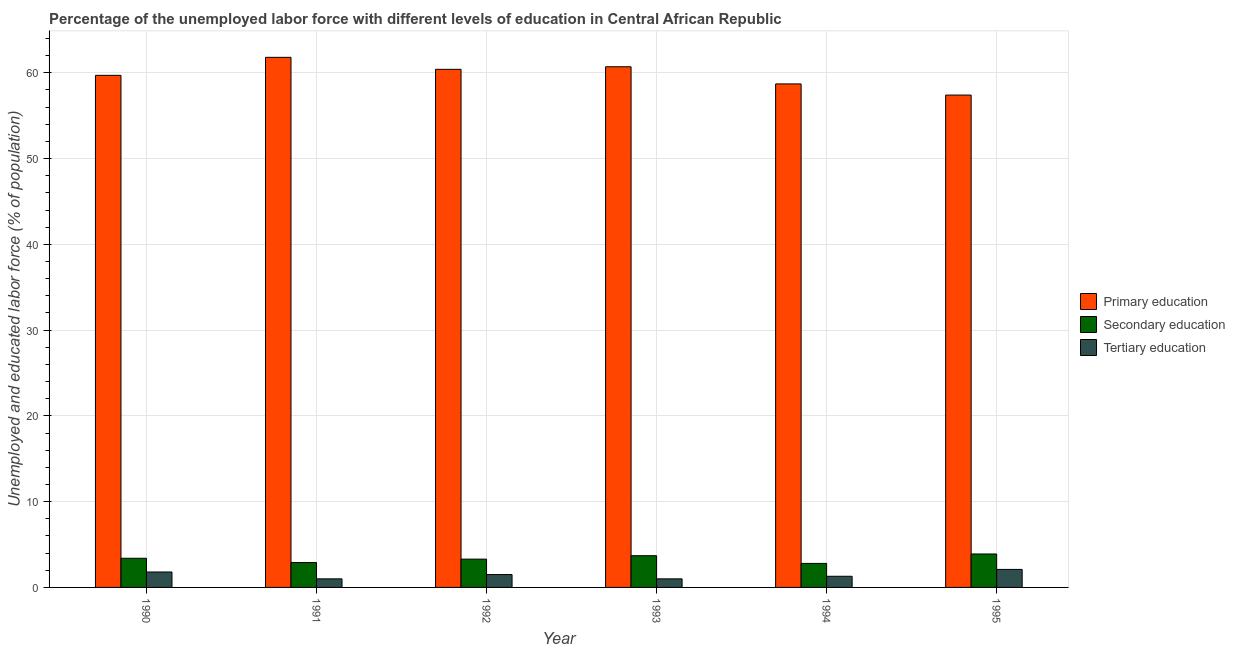Are the number of bars on each tick of the X-axis equal?
Your response must be concise. Yes. What is the label of the 4th group of bars from the left?
Your response must be concise. 1993. What is the percentage of labor force who received secondary education in 1995?
Ensure brevity in your answer.  3.9. Across all years, what is the maximum percentage of labor force who received primary education?
Ensure brevity in your answer.  61.8. Across all years, what is the minimum percentage of labor force who received tertiary education?
Your answer should be compact. 1. What is the total percentage of labor force who received secondary education in the graph?
Make the answer very short. 20. What is the difference between the percentage of labor force who received secondary education in 1994 and that in 1995?
Give a very brief answer. -1.1. What is the difference between the percentage of labor force who received secondary education in 1995 and the percentage of labor force who received tertiary education in 1994?
Make the answer very short. 1.1. What is the average percentage of labor force who received tertiary education per year?
Your response must be concise. 1.45. In the year 1993, what is the difference between the percentage of labor force who received primary education and percentage of labor force who received secondary education?
Your answer should be very brief. 0. What is the ratio of the percentage of labor force who received primary education in 1992 to that in 1993?
Provide a short and direct response. 1. Is the percentage of labor force who received secondary education in 1991 less than that in 1992?
Offer a very short reply. Yes. What is the difference between the highest and the second highest percentage of labor force who received tertiary education?
Your answer should be compact. 0.3. What is the difference between the highest and the lowest percentage of labor force who received secondary education?
Offer a very short reply. 1.1. Is the sum of the percentage of labor force who received tertiary education in 1992 and 1994 greater than the maximum percentage of labor force who received primary education across all years?
Your answer should be very brief. Yes. What does the 3rd bar from the left in 1990 represents?
Provide a succinct answer. Tertiary education. What does the 2nd bar from the right in 1995 represents?
Provide a short and direct response. Secondary education. Is it the case that in every year, the sum of the percentage of labor force who received primary education and percentage of labor force who received secondary education is greater than the percentage of labor force who received tertiary education?
Give a very brief answer. Yes. Are all the bars in the graph horizontal?
Keep it short and to the point. No. What is the difference between two consecutive major ticks on the Y-axis?
Give a very brief answer. 10. Does the graph contain grids?
Provide a succinct answer. Yes. What is the title of the graph?
Ensure brevity in your answer.  Percentage of the unemployed labor force with different levels of education in Central African Republic. What is the label or title of the Y-axis?
Offer a very short reply. Unemployed and educated labor force (% of population). What is the Unemployed and educated labor force (% of population) of Primary education in 1990?
Give a very brief answer. 59.7. What is the Unemployed and educated labor force (% of population) of Secondary education in 1990?
Offer a terse response. 3.4. What is the Unemployed and educated labor force (% of population) of Tertiary education in 1990?
Provide a succinct answer. 1.8. What is the Unemployed and educated labor force (% of population) in Primary education in 1991?
Your answer should be compact. 61.8. What is the Unemployed and educated labor force (% of population) of Secondary education in 1991?
Your answer should be compact. 2.9. What is the Unemployed and educated labor force (% of population) of Primary education in 1992?
Provide a short and direct response. 60.4. What is the Unemployed and educated labor force (% of population) in Secondary education in 1992?
Keep it short and to the point. 3.3. What is the Unemployed and educated labor force (% of population) of Primary education in 1993?
Provide a succinct answer. 60.7. What is the Unemployed and educated labor force (% of population) in Secondary education in 1993?
Give a very brief answer. 3.7. What is the Unemployed and educated labor force (% of population) in Primary education in 1994?
Give a very brief answer. 58.7. What is the Unemployed and educated labor force (% of population) of Secondary education in 1994?
Make the answer very short. 2.8. What is the Unemployed and educated labor force (% of population) of Tertiary education in 1994?
Provide a short and direct response. 1.3. What is the Unemployed and educated labor force (% of population) of Primary education in 1995?
Offer a terse response. 57.4. What is the Unemployed and educated labor force (% of population) in Secondary education in 1995?
Make the answer very short. 3.9. What is the Unemployed and educated labor force (% of population) of Tertiary education in 1995?
Give a very brief answer. 2.1. Across all years, what is the maximum Unemployed and educated labor force (% of population) of Primary education?
Provide a short and direct response. 61.8. Across all years, what is the maximum Unemployed and educated labor force (% of population) in Secondary education?
Your response must be concise. 3.9. Across all years, what is the maximum Unemployed and educated labor force (% of population) in Tertiary education?
Ensure brevity in your answer.  2.1. Across all years, what is the minimum Unemployed and educated labor force (% of population) in Primary education?
Offer a very short reply. 57.4. Across all years, what is the minimum Unemployed and educated labor force (% of population) in Secondary education?
Offer a terse response. 2.8. What is the total Unemployed and educated labor force (% of population) in Primary education in the graph?
Offer a terse response. 358.7. What is the total Unemployed and educated labor force (% of population) of Secondary education in the graph?
Your answer should be compact. 20. What is the total Unemployed and educated labor force (% of population) in Tertiary education in the graph?
Provide a succinct answer. 8.7. What is the difference between the Unemployed and educated labor force (% of population) of Secondary education in 1990 and that in 1991?
Make the answer very short. 0.5. What is the difference between the Unemployed and educated labor force (% of population) in Tertiary education in 1990 and that in 1991?
Provide a short and direct response. 0.8. What is the difference between the Unemployed and educated labor force (% of population) in Primary education in 1990 and that in 1993?
Your answer should be very brief. -1. What is the difference between the Unemployed and educated labor force (% of population) in Tertiary education in 1990 and that in 1993?
Offer a very short reply. 0.8. What is the difference between the Unemployed and educated labor force (% of population) in Secondary education in 1990 and that in 1994?
Offer a terse response. 0.6. What is the difference between the Unemployed and educated labor force (% of population) in Tertiary education in 1990 and that in 1994?
Keep it short and to the point. 0.5. What is the difference between the Unemployed and educated labor force (% of population) of Secondary education in 1990 and that in 1995?
Make the answer very short. -0.5. What is the difference between the Unemployed and educated labor force (% of population) in Tertiary education in 1990 and that in 1995?
Offer a terse response. -0.3. What is the difference between the Unemployed and educated labor force (% of population) of Primary education in 1991 and that in 1992?
Keep it short and to the point. 1.4. What is the difference between the Unemployed and educated labor force (% of population) in Secondary education in 1991 and that in 1992?
Give a very brief answer. -0.4. What is the difference between the Unemployed and educated labor force (% of population) of Tertiary education in 1991 and that in 1992?
Your answer should be very brief. -0.5. What is the difference between the Unemployed and educated labor force (% of population) of Secondary education in 1991 and that in 1993?
Make the answer very short. -0.8. What is the difference between the Unemployed and educated labor force (% of population) of Secondary education in 1991 and that in 1994?
Offer a terse response. 0.1. What is the difference between the Unemployed and educated labor force (% of population) of Tertiary education in 1991 and that in 1995?
Your response must be concise. -1.1. What is the difference between the Unemployed and educated labor force (% of population) of Secondary education in 1992 and that in 1993?
Your answer should be compact. -0.4. What is the difference between the Unemployed and educated labor force (% of population) in Primary education in 1992 and that in 1994?
Offer a very short reply. 1.7. What is the difference between the Unemployed and educated labor force (% of population) of Tertiary education in 1992 and that in 1994?
Provide a succinct answer. 0.2. What is the difference between the Unemployed and educated labor force (% of population) in Secondary education in 1992 and that in 1995?
Provide a succinct answer. -0.6. What is the difference between the Unemployed and educated labor force (% of population) in Primary education in 1993 and that in 1994?
Give a very brief answer. 2. What is the difference between the Unemployed and educated labor force (% of population) in Secondary education in 1993 and that in 1994?
Ensure brevity in your answer.  0.9. What is the difference between the Unemployed and educated labor force (% of population) in Secondary education in 1994 and that in 1995?
Provide a short and direct response. -1.1. What is the difference between the Unemployed and educated labor force (% of population) of Tertiary education in 1994 and that in 1995?
Ensure brevity in your answer.  -0.8. What is the difference between the Unemployed and educated labor force (% of population) in Primary education in 1990 and the Unemployed and educated labor force (% of population) in Secondary education in 1991?
Provide a succinct answer. 56.8. What is the difference between the Unemployed and educated labor force (% of population) in Primary education in 1990 and the Unemployed and educated labor force (% of population) in Tertiary education in 1991?
Provide a succinct answer. 58.7. What is the difference between the Unemployed and educated labor force (% of population) in Primary education in 1990 and the Unemployed and educated labor force (% of population) in Secondary education in 1992?
Provide a short and direct response. 56.4. What is the difference between the Unemployed and educated labor force (% of population) in Primary education in 1990 and the Unemployed and educated labor force (% of population) in Tertiary education in 1992?
Provide a short and direct response. 58.2. What is the difference between the Unemployed and educated labor force (% of population) of Secondary education in 1990 and the Unemployed and educated labor force (% of population) of Tertiary education in 1992?
Offer a very short reply. 1.9. What is the difference between the Unemployed and educated labor force (% of population) in Primary education in 1990 and the Unemployed and educated labor force (% of population) in Tertiary education in 1993?
Make the answer very short. 58.7. What is the difference between the Unemployed and educated labor force (% of population) in Secondary education in 1990 and the Unemployed and educated labor force (% of population) in Tertiary education in 1993?
Offer a terse response. 2.4. What is the difference between the Unemployed and educated labor force (% of population) in Primary education in 1990 and the Unemployed and educated labor force (% of population) in Secondary education in 1994?
Make the answer very short. 56.9. What is the difference between the Unemployed and educated labor force (% of population) of Primary education in 1990 and the Unemployed and educated labor force (% of population) of Tertiary education in 1994?
Offer a terse response. 58.4. What is the difference between the Unemployed and educated labor force (% of population) of Primary education in 1990 and the Unemployed and educated labor force (% of population) of Secondary education in 1995?
Your response must be concise. 55.8. What is the difference between the Unemployed and educated labor force (% of population) in Primary education in 1990 and the Unemployed and educated labor force (% of population) in Tertiary education in 1995?
Offer a very short reply. 57.6. What is the difference between the Unemployed and educated labor force (% of population) of Primary education in 1991 and the Unemployed and educated labor force (% of population) of Secondary education in 1992?
Provide a short and direct response. 58.5. What is the difference between the Unemployed and educated labor force (% of population) of Primary education in 1991 and the Unemployed and educated labor force (% of population) of Tertiary education in 1992?
Offer a very short reply. 60.3. What is the difference between the Unemployed and educated labor force (% of population) of Primary education in 1991 and the Unemployed and educated labor force (% of population) of Secondary education in 1993?
Offer a very short reply. 58.1. What is the difference between the Unemployed and educated labor force (% of population) of Primary education in 1991 and the Unemployed and educated labor force (% of population) of Tertiary education in 1993?
Keep it short and to the point. 60.8. What is the difference between the Unemployed and educated labor force (% of population) of Secondary education in 1991 and the Unemployed and educated labor force (% of population) of Tertiary education in 1993?
Provide a succinct answer. 1.9. What is the difference between the Unemployed and educated labor force (% of population) of Primary education in 1991 and the Unemployed and educated labor force (% of population) of Secondary education in 1994?
Provide a short and direct response. 59. What is the difference between the Unemployed and educated labor force (% of population) of Primary education in 1991 and the Unemployed and educated labor force (% of population) of Tertiary education in 1994?
Give a very brief answer. 60.5. What is the difference between the Unemployed and educated labor force (% of population) of Primary education in 1991 and the Unemployed and educated labor force (% of population) of Secondary education in 1995?
Keep it short and to the point. 57.9. What is the difference between the Unemployed and educated labor force (% of population) in Primary education in 1991 and the Unemployed and educated labor force (% of population) in Tertiary education in 1995?
Give a very brief answer. 59.7. What is the difference between the Unemployed and educated labor force (% of population) in Primary education in 1992 and the Unemployed and educated labor force (% of population) in Secondary education in 1993?
Provide a succinct answer. 56.7. What is the difference between the Unemployed and educated labor force (% of population) of Primary education in 1992 and the Unemployed and educated labor force (% of population) of Tertiary education in 1993?
Your answer should be compact. 59.4. What is the difference between the Unemployed and educated labor force (% of population) of Primary education in 1992 and the Unemployed and educated labor force (% of population) of Secondary education in 1994?
Offer a terse response. 57.6. What is the difference between the Unemployed and educated labor force (% of population) of Primary education in 1992 and the Unemployed and educated labor force (% of population) of Tertiary education in 1994?
Offer a terse response. 59.1. What is the difference between the Unemployed and educated labor force (% of population) of Primary education in 1992 and the Unemployed and educated labor force (% of population) of Secondary education in 1995?
Your response must be concise. 56.5. What is the difference between the Unemployed and educated labor force (% of population) of Primary education in 1992 and the Unemployed and educated labor force (% of population) of Tertiary education in 1995?
Offer a terse response. 58.3. What is the difference between the Unemployed and educated labor force (% of population) of Secondary education in 1992 and the Unemployed and educated labor force (% of population) of Tertiary education in 1995?
Offer a very short reply. 1.2. What is the difference between the Unemployed and educated labor force (% of population) in Primary education in 1993 and the Unemployed and educated labor force (% of population) in Secondary education in 1994?
Your answer should be compact. 57.9. What is the difference between the Unemployed and educated labor force (% of population) in Primary education in 1993 and the Unemployed and educated labor force (% of population) in Tertiary education in 1994?
Your answer should be very brief. 59.4. What is the difference between the Unemployed and educated labor force (% of population) in Secondary education in 1993 and the Unemployed and educated labor force (% of population) in Tertiary education in 1994?
Offer a very short reply. 2.4. What is the difference between the Unemployed and educated labor force (% of population) of Primary education in 1993 and the Unemployed and educated labor force (% of population) of Secondary education in 1995?
Provide a short and direct response. 56.8. What is the difference between the Unemployed and educated labor force (% of population) in Primary education in 1993 and the Unemployed and educated labor force (% of population) in Tertiary education in 1995?
Your answer should be compact. 58.6. What is the difference between the Unemployed and educated labor force (% of population) of Primary education in 1994 and the Unemployed and educated labor force (% of population) of Secondary education in 1995?
Provide a short and direct response. 54.8. What is the difference between the Unemployed and educated labor force (% of population) of Primary education in 1994 and the Unemployed and educated labor force (% of population) of Tertiary education in 1995?
Offer a terse response. 56.6. What is the average Unemployed and educated labor force (% of population) of Primary education per year?
Give a very brief answer. 59.78. What is the average Unemployed and educated labor force (% of population) of Secondary education per year?
Offer a very short reply. 3.33. What is the average Unemployed and educated labor force (% of population) of Tertiary education per year?
Make the answer very short. 1.45. In the year 1990, what is the difference between the Unemployed and educated labor force (% of population) in Primary education and Unemployed and educated labor force (% of population) in Secondary education?
Provide a succinct answer. 56.3. In the year 1990, what is the difference between the Unemployed and educated labor force (% of population) in Primary education and Unemployed and educated labor force (% of population) in Tertiary education?
Give a very brief answer. 57.9. In the year 1990, what is the difference between the Unemployed and educated labor force (% of population) in Secondary education and Unemployed and educated labor force (% of population) in Tertiary education?
Provide a short and direct response. 1.6. In the year 1991, what is the difference between the Unemployed and educated labor force (% of population) of Primary education and Unemployed and educated labor force (% of population) of Secondary education?
Ensure brevity in your answer.  58.9. In the year 1991, what is the difference between the Unemployed and educated labor force (% of population) in Primary education and Unemployed and educated labor force (% of population) in Tertiary education?
Make the answer very short. 60.8. In the year 1992, what is the difference between the Unemployed and educated labor force (% of population) in Primary education and Unemployed and educated labor force (% of population) in Secondary education?
Your response must be concise. 57.1. In the year 1992, what is the difference between the Unemployed and educated labor force (% of population) of Primary education and Unemployed and educated labor force (% of population) of Tertiary education?
Provide a succinct answer. 58.9. In the year 1993, what is the difference between the Unemployed and educated labor force (% of population) in Primary education and Unemployed and educated labor force (% of population) in Tertiary education?
Provide a short and direct response. 59.7. In the year 1993, what is the difference between the Unemployed and educated labor force (% of population) in Secondary education and Unemployed and educated labor force (% of population) in Tertiary education?
Your answer should be compact. 2.7. In the year 1994, what is the difference between the Unemployed and educated labor force (% of population) in Primary education and Unemployed and educated labor force (% of population) in Secondary education?
Offer a very short reply. 55.9. In the year 1994, what is the difference between the Unemployed and educated labor force (% of population) in Primary education and Unemployed and educated labor force (% of population) in Tertiary education?
Your answer should be very brief. 57.4. In the year 1994, what is the difference between the Unemployed and educated labor force (% of population) in Secondary education and Unemployed and educated labor force (% of population) in Tertiary education?
Your answer should be compact. 1.5. In the year 1995, what is the difference between the Unemployed and educated labor force (% of population) in Primary education and Unemployed and educated labor force (% of population) in Secondary education?
Give a very brief answer. 53.5. In the year 1995, what is the difference between the Unemployed and educated labor force (% of population) of Primary education and Unemployed and educated labor force (% of population) of Tertiary education?
Your answer should be very brief. 55.3. What is the ratio of the Unemployed and educated labor force (% of population) in Primary education in 1990 to that in 1991?
Give a very brief answer. 0.97. What is the ratio of the Unemployed and educated labor force (% of population) of Secondary education in 1990 to that in 1991?
Offer a terse response. 1.17. What is the ratio of the Unemployed and educated labor force (% of population) in Tertiary education in 1990 to that in 1991?
Your answer should be compact. 1.8. What is the ratio of the Unemployed and educated labor force (% of population) in Primary education in 1990 to that in 1992?
Offer a very short reply. 0.99. What is the ratio of the Unemployed and educated labor force (% of population) in Secondary education in 1990 to that in 1992?
Provide a short and direct response. 1.03. What is the ratio of the Unemployed and educated labor force (% of population) in Primary education in 1990 to that in 1993?
Give a very brief answer. 0.98. What is the ratio of the Unemployed and educated labor force (% of population) in Secondary education in 1990 to that in 1993?
Your answer should be very brief. 0.92. What is the ratio of the Unemployed and educated labor force (% of population) in Tertiary education in 1990 to that in 1993?
Provide a short and direct response. 1.8. What is the ratio of the Unemployed and educated labor force (% of population) in Secondary education in 1990 to that in 1994?
Offer a terse response. 1.21. What is the ratio of the Unemployed and educated labor force (% of population) in Tertiary education in 1990 to that in 1994?
Offer a very short reply. 1.38. What is the ratio of the Unemployed and educated labor force (% of population) in Primary education in 1990 to that in 1995?
Provide a short and direct response. 1.04. What is the ratio of the Unemployed and educated labor force (% of population) in Secondary education in 1990 to that in 1995?
Offer a terse response. 0.87. What is the ratio of the Unemployed and educated labor force (% of population) of Tertiary education in 1990 to that in 1995?
Provide a short and direct response. 0.86. What is the ratio of the Unemployed and educated labor force (% of population) in Primary education in 1991 to that in 1992?
Your answer should be very brief. 1.02. What is the ratio of the Unemployed and educated labor force (% of population) in Secondary education in 1991 to that in 1992?
Provide a succinct answer. 0.88. What is the ratio of the Unemployed and educated labor force (% of population) in Primary education in 1991 to that in 1993?
Ensure brevity in your answer.  1.02. What is the ratio of the Unemployed and educated labor force (% of population) of Secondary education in 1991 to that in 1993?
Make the answer very short. 0.78. What is the ratio of the Unemployed and educated labor force (% of population) of Tertiary education in 1991 to that in 1993?
Make the answer very short. 1. What is the ratio of the Unemployed and educated labor force (% of population) of Primary education in 1991 to that in 1994?
Your answer should be very brief. 1.05. What is the ratio of the Unemployed and educated labor force (% of population) in Secondary education in 1991 to that in 1994?
Make the answer very short. 1.04. What is the ratio of the Unemployed and educated labor force (% of population) in Tertiary education in 1991 to that in 1994?
Your answer should be very brief. 0.77. What is the ratio of the Unemployed and educated labor force (% of population) of Primary education in 1991 to that in 1995?
Offer a very short reply. 1.08. What is the ratio of the Unemployed and educated labor force (% of population) in Secondary education in 1991 to that in 1995?
Keep it short and to the point. 0.74. What is the ratio of the Unemployed and educated labor force (% of population) of Tertiary education in 1991 to that in 1995?
Your answer should be compact. 0.48. What is the ratio of the Unemployed and educated labor force (% of population) in Secondary education in 1992 to that in 1993?
Your response must be concise. 0.89. What is the ratio of the Unemployed and educated labor force (% of population) in Tertiary education in 1992 to that in 1993?
Keep it short and to the point. 1.5. What is the ratio of the Unemployed and educated labor force (% of population) of Secondary education in 1992 to that in 1994?
Your response must be concise. 1.18. What is the ratio of the Unemployed and educated labor force (% of population) in Tertiary education in 1992 to that in 1994?
Ensure brevity in your answer.  1.15. What is the ratio of the Unemployed and educated labor force (% of population) of Primary education in 1992 to that in 1995?
Your response must be concise. 1.05. What is the ratio of the Unemployed and educated labor force (% of population) in Secondary education in 1992 to that in 1995?
Provide a short and direct response. 0.85. What is the ratio of the Unemployed and educated labor force (% of population) in Tertiary education in 1992 to that in 1995?
Keep it short and to the point. 0.71. What is the ratio of the Unemployed and educated labor force (% of population) in Primary education in 1993 to that in 1994?
Keep it short and to the point. 1.03. What is the ratio of the Unemployed and educated labor force (% of population) of Secondary education in 1993 to that in 1994?
Provide a succinct answer. 1.32. What is the ratio of the Unemployed and educated labor force (% of population) in Tertiary education in 1993 to that in 1994?
Provide a short and direct response. 0.77. What is the ratio of the Unemployed and educated labor force (% of population) in Primary education in 1993 to that in 1995?
Offer a very short reply. 1.06. What is the ratio of the Unemployed and educated labor force (% of population) in Secondary education in 1993 to that in 1995?
Offer a very short reply. 0.95. What is the ratio of the Unemployed and educated labor force (% of population) of Tertiary education in 1993 to that in 1995?
Give a very brief answer. 0.48. What is the ratio of the Unemployed and educated labor force (% of population) of Primary education in 1994 to that in 1995?
Offer a very short reply. 1.02. What is the ratio of the Unemployed and educated labor force (% of population) in Secondary education in 1994 to that in 1995?
Your response must be concise. 0.72. What is the ratio of the Unemployed and educated labor force (% of population) in Tertiary education in 1994 to that in 1995?
Make the answer very short. 0.62. What is the difference between the highest and the second highest Unemployed and educated labor force (% of population) in Primary education?
Provide a succinct answer. 1.1. What is the difference between the highest and the second highest Unemployed and educated labor force (% of population) in Secondary education?
Make the answer very short. 0.2. 